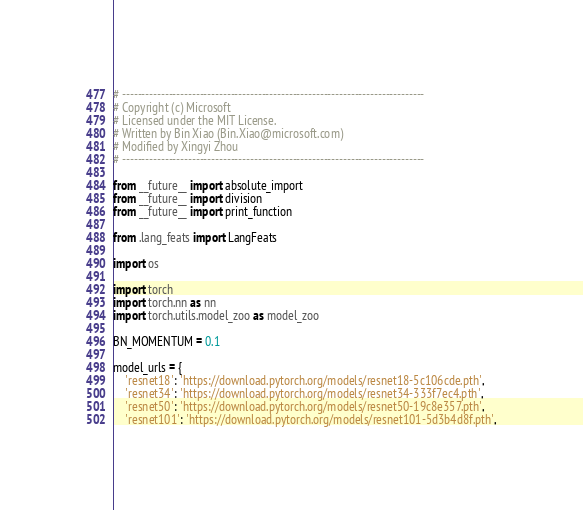Convert code to text. <code><loc_0><loc_0><loc_500><loc_500><_Python_># ------------------------------------------------------------------------------
# Copyright (c) Microsoft
# Licensed under the MIT License.
# Written by Bin Xiao (Bin.Xiao@microsoft.com)
# Modified by Xingyi Zhou
# ------------------------------------------------------------------------------

from __future__ import absolute_import
from __future__ import division
from __future__ import print_function

from .lang_feats import LangFeats

import os

import torch
import torch.nn as nn
import torch.utils.model_zoo as model_zoo

BN_MOMENTUM = 0.1

model_urls = {
    'resnet18': 'https://download.pytorch.org/models/resnet18-5c106cde.pth',
    'resnet34': 'https://download.pytorch.org/models/resnet34-333f7ec4.pth',
    'resnet50': 'https://download.pytorch.org/models/resnet50-19c8e357.pth',
    'resnet101': 'https://download.pytorch.org/models/resnet101-5d3b4d8f.pth',</code> 